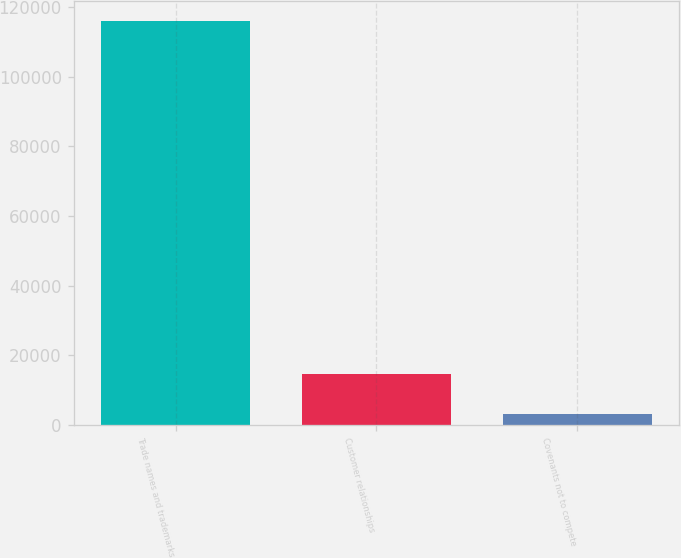<chart> <loc_0><loc_0><loc_500><loc_500><bar_chart><fcel>Trade names and trademarks<fcel>Customer relationships<fcel>Covenants not to compete<nl><fcel>115954<fcel>14470<fcel>3194<nl></chart> 